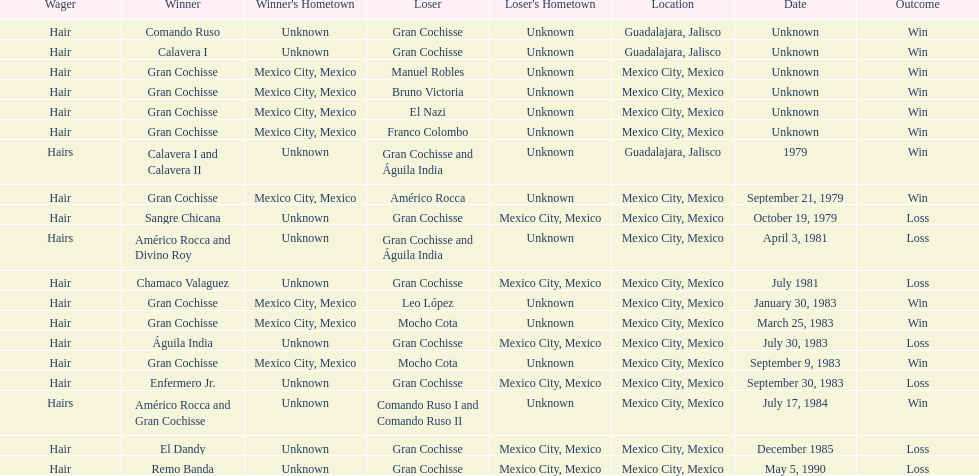Can you give me this table as a dict? {'header': ['Wager', 'Winner', "Winner's Hometown", 'Loser', "Loser's Hometown", 'Location', 'Date', 'Outcome'], 'rows': [['Hair', 'Comando Ruso', 'Unknown', 'Gran Cochisse', 'Unknown', 'Guadalajara, Jalisco', 'Unknown', 'Win'], ['Hair', 'Calavera I', 'Unknown', 'Gran Cochisse', 'Unknown', 'Guadalajara, Jalisco', 'Unknown', 'Win'], ['Hair', 'Gran Cochisse', 'Mexico City, Mexico', 'Manuel Robles', 'Unknown', 'Mexico City, Mexico', 'Unknown', 'Win'], ['Hair', 'Gran Cochisse', 'Mexico City, Mexico', 'Bruno Victoria', 'Unknown', 'Mexico City, Mexico', 'Unknown', 'Win'], ['Hair', 'Gran Cochisse', 'Mexico City, Mexico', 'El Nazi', 'Unknown', 'Mexico City, Mexico', 'Unknown', 'Win'], ['Hair', 'Gran Cochisse', 'Mexico City, Mexico', 'Franco Colombo', 'Unknown', 'Mexico City, Mexico', 'Unknown', 'Win'], ['Hairs', 'Calavera I and Calavera II', 'Unknown', 'Gran Cochisse and Águila India', 'Unknown', 'Guadalajara, Jalisco', '1979', 'Win'], ['Hair', 'Gran Cochisse', 'Mexico City, Mexico', 'Américo Rocca', 'Unknown', 'Mexico City, Mexico', 'September 21, 1979', 'Win'], ['Hair', 'Sangre Chicana', 'Unknown', 'Gran Cochisse', 'Mexico City, Mexico', 'Mexico City, Mexico', 'October 19, 1979', 'Loss'], ['Hairs', 'Américo Rocca and Divino Roy', 'Unknown', 'Gran Cochisse and Águila India', 'Unknown', 'Mexico City, Mexico', 'April 3, 1981', 'Loss'], ['Hair', 'Chamaco Valaguez', 'Unknown', 'Gran Cochisse', 'Mexico City, Mexico', 'Mexico City, Mexico', 'July 1981', 'Loss'], ['Hair', 'Gran Cochisse', 'Mexico City, Mexico', 'Leo López', 'Unknown', 'Mexico City, Mexico', 'January 30, 1983', 'Win'], ['Hair', 'Gran Cochisse', 'Mexico City, Mexico', 'Mocho Cota', 'Unknown', 'Mexico City, Mexico', 'March 25, 1983', 'Win'], ['Hair', 'Águila India', 'Unknown', 'Gran Cochisse', 'Mexico City, Mexico', 'Mexico City, Mexico', 'July 30, 1983', 'Loss'], ['Hair', 'Gran Cochisse', 'Mexico City, Mexico', 'Mocho Cota', 'Unknown', 'Mexico City, Mexico', 'September 9, 1983', 'Win'], ['Hair', 'Enfermero Jr.', 'Unknown', 'Gran Cochisse', 'Mexico City, Mexico', 'Mexico City, Mexico', 'September 30, 1983', 'Loss'], ['Hairs', 'Américo Rocca and Gran Cochisse', 'Unknown', 'Comando Ruso I and Comando Ruso II', 'Unknown', 'Mexico City, Mexico', 'July 17, 1984', 'Win'], ['Hair', 'El Dandy', 'Unknown', 'Gran Cochisse', 'Mexico City, Mexico', 'Mexico City, Mexico', 'December 1985', 'Loss'], ['Hair', 'Remo Banda', 'Unknown', 'Gran Cochisse', 'Mexico City, Mexico', 'Mexico City, Mexico', 'May 5, 1990', 'Loss']]} When was gran chochisse first match that had a full date on record? September 21, 1979. 